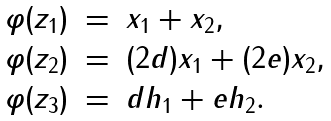Convert formula to latex. <formula><loc_0><loc_0><loc_500><loc_500>\begin{array} { l l l l l l } \varphi ( z _ { 1 } ) & = & x _ { 1 } + x _ { 2 } , \\ \varphi ( z _ { 2 } ) & = & ( 2 d ) x _ { 1 } + ( 2 e ) x _ { 2 } , \\ \varphi ( z _ { 3 } ) & = & d h _ { 1 } + e h _ { 2 } . \end{array}</formula> 